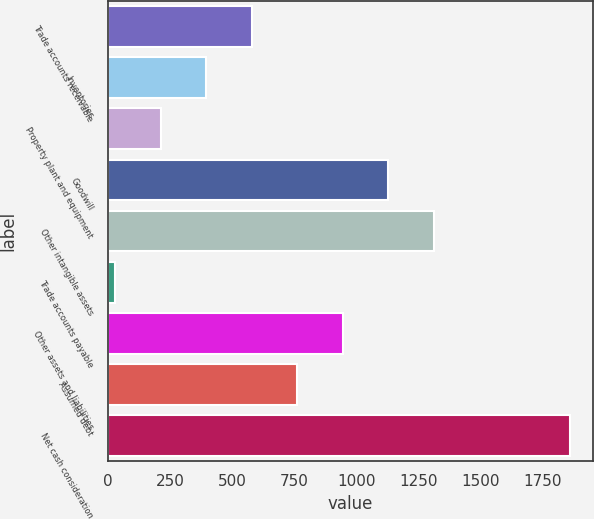Convert chart. <chart><loc_0><loc_0><loc_500><loc_500><bar_chart><fcel>Trade accounts receivable<fcel>Inventories<fcel>Property plant and equipment<fcel>Goodwill<fcel>Other intangible assets<fcel>Trade accounts payable<fcel>Other assets and liabilities<fcel>Assumed debt<fcel>Net cash consideration<nl><fcel>580.07<fcel>396.98<fcel>213.89<fcel>1129.34<fcel>1312.43<fcel>30.8<fcel>946.25<fcel>763.16<fcel>1861.7<nl></chart> 